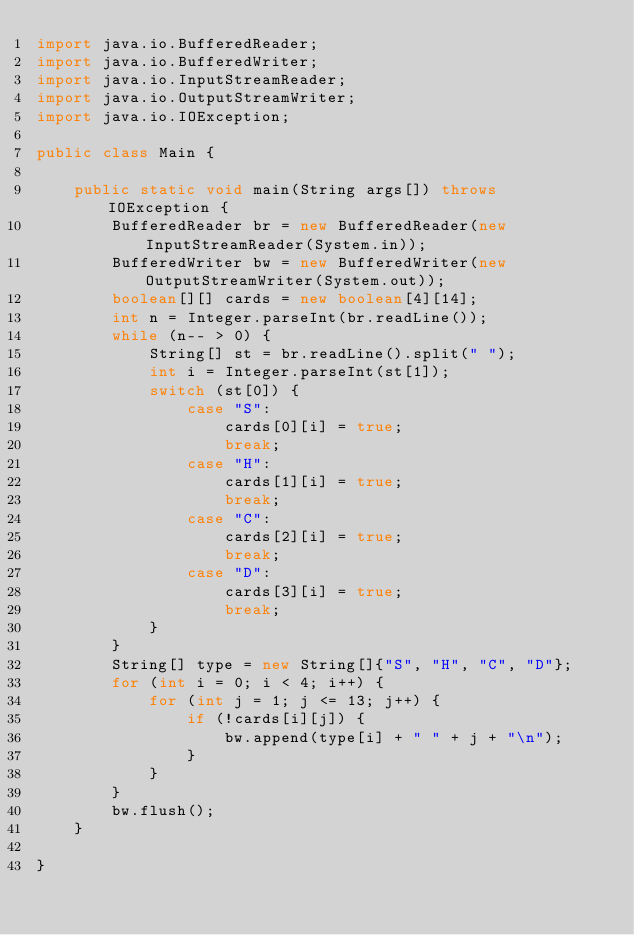<code> <loc_0><loc_0><loc_500><loc_500><_Java_>import java.io.BufferedReader;
import java.io.BufferedWriter;
import java.io.InputStreamReader;
import java.io.OutputStreamWriter;
import java.io.IOException;

public class Main {

    public static void main(String args[]) throws IOException {
        BufferedReader br = new BufferedReader(new InputStreamReader(System.in));
        BufferedWriter bw = new BufferedWriter(new OutputStreamWriter(System.out));
        boolean[][] cards = new boolean[4][14];
        int n = Integer.parseInt(br.readLine());
        while (n-- > 0) {
            String[] st = br.readLine().split(" ");
            int i = Integer.parseInt(st[1]);
            switch (st[0]) {
                case "S":
                    cards[0][i] = true;
                    break;
                case "H":
                    cards[1][i] = true;
                    break;
                case "C":
                    cards[2][i] = true;
                    break;
                case "D":
                    cards[3][i] = true;
                    break;
            }
        }
        String[] type = new String[]{"S", "H", "C", "D"};
        for (int i = 0; i < 4; i++) {
            for (int j = 1; j <= 13; j++) {
                if (!cards[i][j]) {
                    bw.append(type[i] + " " + j + "\n");
                }
            }
        }
        bw.flush();
    }
    
}
</code> 